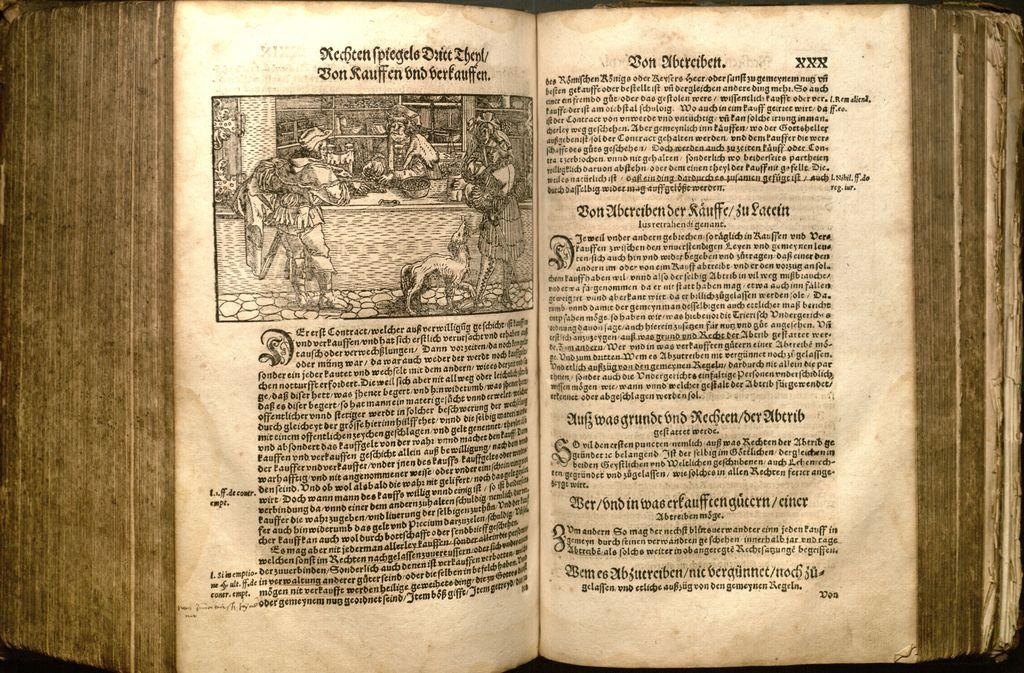Provide a one-sentence caption for the provided image. an old German tome open to a page with Bon Ubereibett on it. 